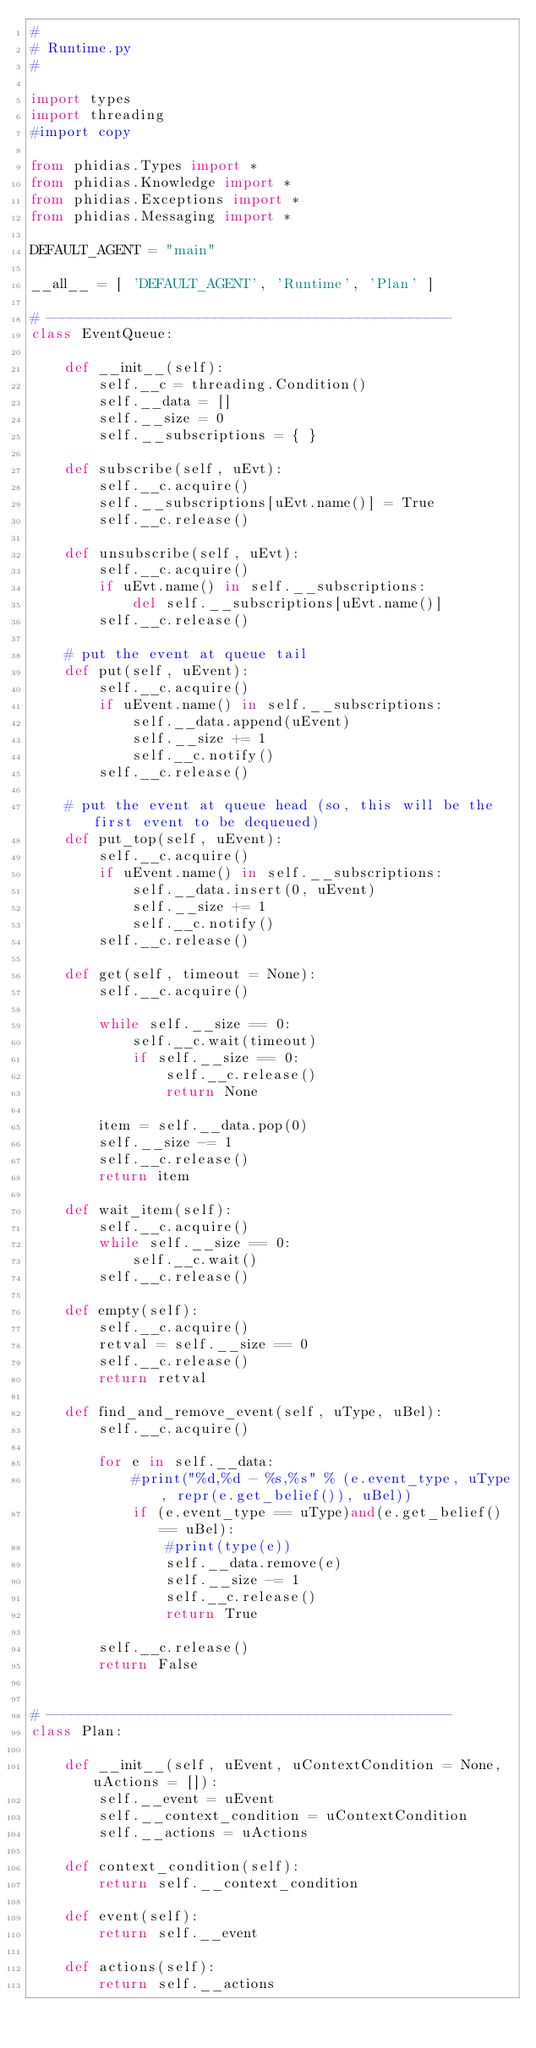Convert code to text. <code><loc_0><loc_0><loc_500><loc_500><_Python_>#
# Runtime.py
#

import types
import threading
#import copy

from phidias.Types import *
from phidias.Knowledge import *
from phidias.Exceptions import *
from phidias.Messaging import *

DEFAULT_AGENT = "main"

__all__ = [ 'DEFAULT_AGENT', 'Runtime', 'Plan' ]

# ------------------------------------------------
class EventQueue:

    def __init__(self):
        self.__c = threading.Condition()
        self.__data = []
        self.__size = 0
        self.__subscriptions = { }

    def subscribe(self, uEvt):
        self.__c.acquire()
        self.__subscriptions[uEvt.name()] = True
        self.__c.release()

    def unsubscribe(self, uEvt):
        self.__c.acquire()
        if uEvt.name() in self.__subscriptions:
            del self.__subscriptions[uEvt.name()]
        self.__c.release()

    # put the event at queue tail
    def put(self, uEvent):
        self.__c.acquire()
        if uEvent.name() in self.__subscriptions:
            self.__data.append(uEvent)
            self.__size += 1
            self.__c.notify()
        self.__c.release()

    # put the event at queue head (so, this will be the first event to be dequeued)
    def put_top(self, uEvent):
        self.__c.acquire()
        if uEvent.name() in self.__subscriptions:
            self.__data.insert(0, uEvent)
            self.__size += 1
            self.__c.notify()
        self.__c.release()

    def get(self, timeout = None):
        self.__c.acquire()

        while self.__size == 0:
            self.__c.wait(timeout)
            if self.__size == 0:
                self.__c.release()
                return None

        item = self.__data.pop(0)
        self.__size -= 1
        self.__c.release()
        return item

    def wait_item(self):
        self.__c.acquire()
        while self.__size == 0:
            self.__c.wait()
        self.__c.release()

    def empty(self):
        self.__c.acquire()
        retval = self.__size == 0
        self.__c.release()
        return retval

    def find_and_remove_event(self, uType, uBel):
        self.__c.acquire()

        for e in self.__data:
            #print("%d,%d - %s,%s" % (e.event_type, uType, repr(e.get_belief()), uBel))
            if (e.event_type == uType)and(e.get_belief() == uBel):
                #print(type(e))
                self.__data.remove(e)
                self.__size -= 1
                self.__c.release()
                return True

        self.__c.release()
        return False


# ------------------------------------------------
class Plan:

    def __init__(self, uEvent, uContextCondition = None, uActions = []):
        self.__event = uEvent
        self.__context_condition = uContextCondition
        self.__actions = uActions

    def context_condition(self):
        return self.__context_condition

    def event(self):
        return self.__event

    def actions(self):
        return self.__actions
</code> 